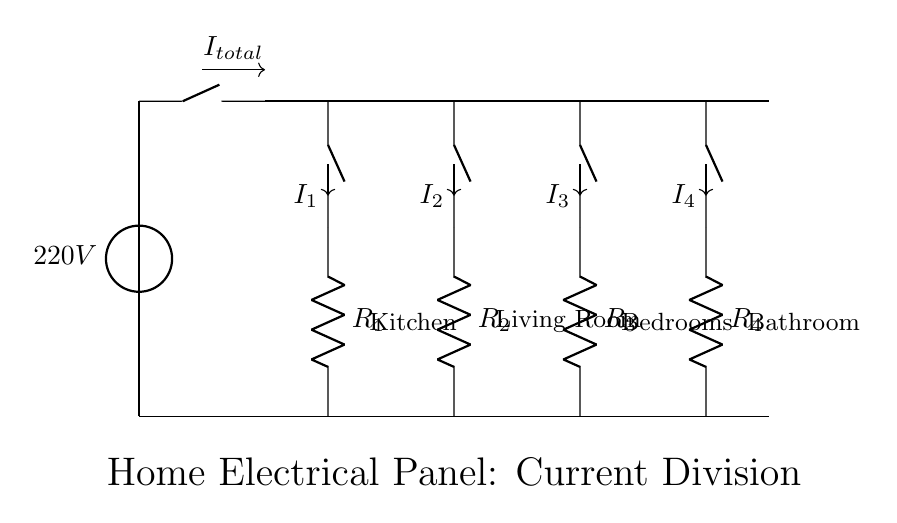What is the total voltage supplied to the panel? The total voltage is indicated by the voltage source at the top of the diagram, which is clearly labeled as 220V.
Answer: 220V What are the names of the branches connected to the panel? The branches are labeled as Kitchen, Living Room, Bedrooms, and Bathroom, indicating which area of the home each branch supplies power to.
Answer: Kitchen, Living Room, Bedrooms, Bathroom How many resistors are present in this circuit? The diagram shows four branches, each containing one resistor labeled R1, R2, R3, and R4, resulting in a total of four resistors.
Answer: 4 Which branch would carry the highest current if all resistances are equal? Since all resistances are equal, the branch corresponding to the largest load would distribute the highest current. However, in this case, the branch names don't have specific loads mentioned, so it's indeterminate.
Answer: Indeterminate based on current information What happens to the current if one branch is added or removed? Adding a branch would decrease the total resistance, which could increase the total current from the source, while removing a branch would increase the resistance and potentially decrease the total current, as per Ohm's Law.
Answer: Current increases or decreases What is the current going through the Kitchen branch? The current in the Kitchen branch (I1) is indicated by the labeling on the circuit diagram, but without additional numerical values for resistance, it cannot be determined specifically from this diagram alone.
Answer: Indeterminate without values What type of circuit configuration is shown in this diagram? This circuit configuration is a parallel circuit, as multiple branches are connected directly to the same voltage source without passing through each other.
Answer: Parallel circuit 